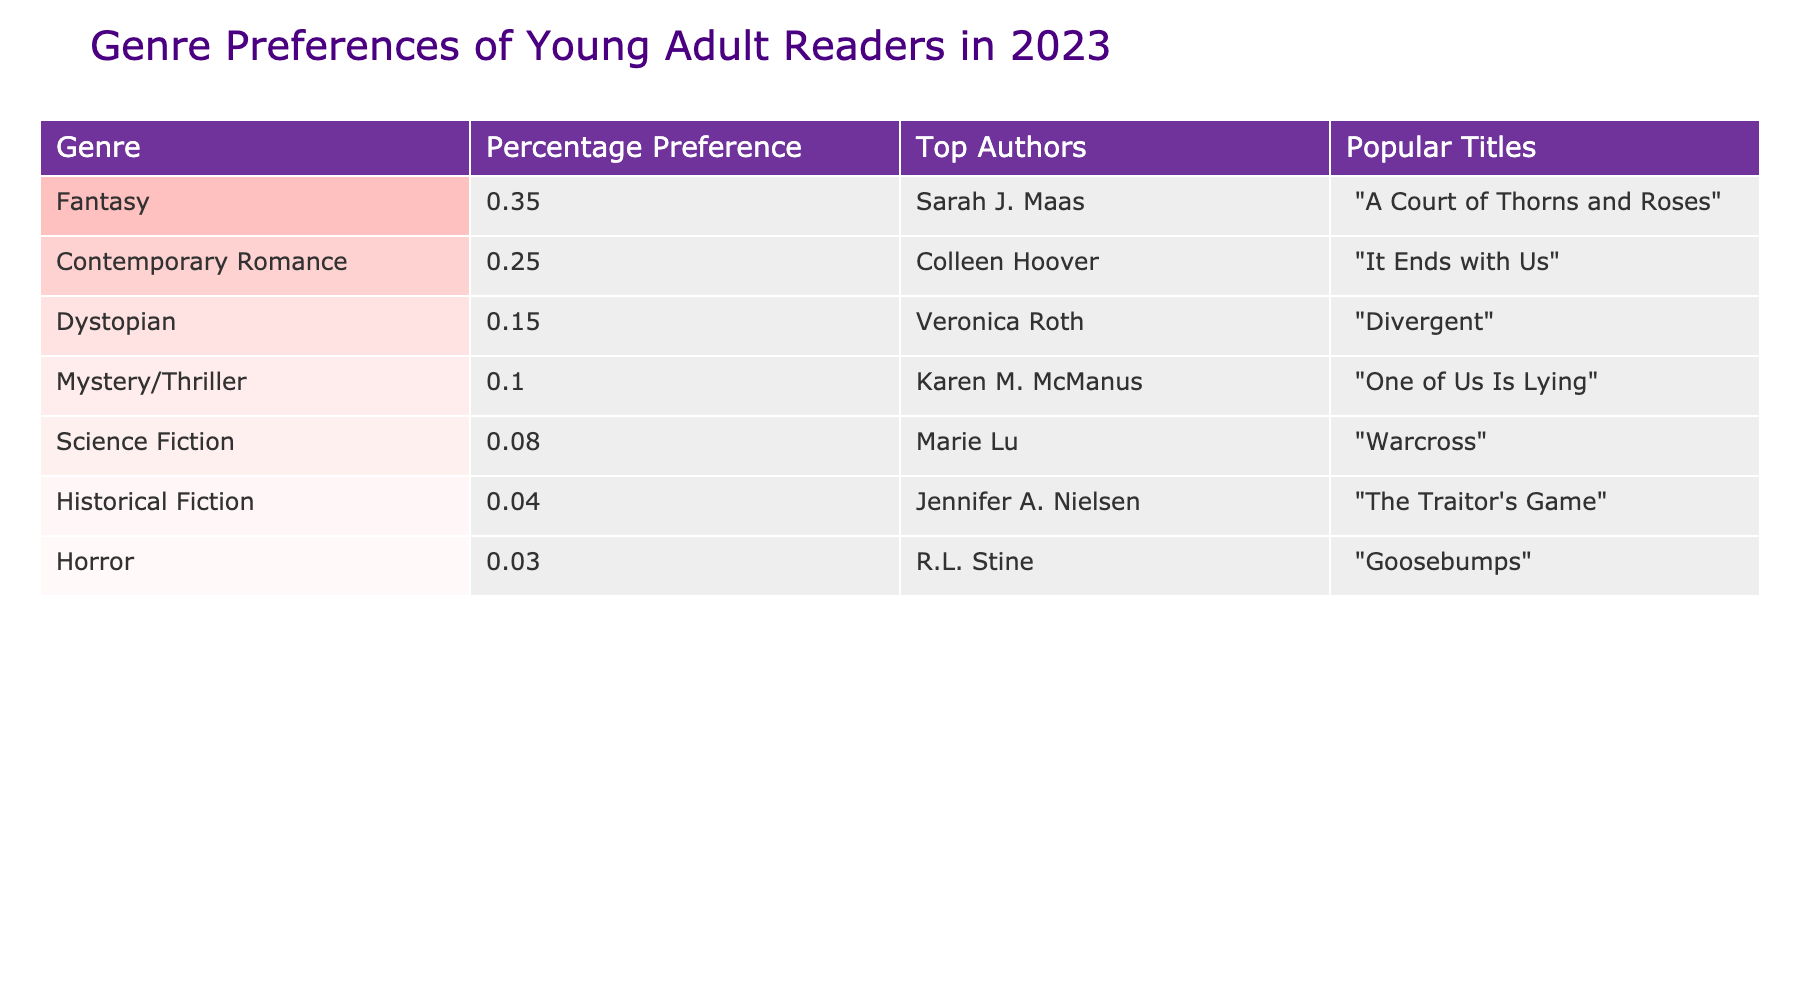What percentage of young adult readers prefer Fantasy? The table shows that the percentage preference for Fantasy is listed in the first row under "Percentage Preference," which is 35%.
Answer: 35% Which genre has the lowest percentage preference? By examining the "Percentage Preference" column, Horror is listed at 3%, which is the lowest percentage among all genres.
Answer: Horror Who is the top author for Contemporary Romance? The table lists Colleen Hoover as the top author for Contemporary Romance in the "Top Authors" column corresponding to the 25% preference in that genre.
Answer: Colleen Hoover What is the difference in percentage preference between Fantasy and Science Fiction? The percentage preference for Fantasy is 35% and for Science Fiction it is 8%. The difference is calculated as 35% - 8% = 27%.
Answer: 27% What is the combined percentage preference for Dystopian and Historical Fiction? The percentage preference for Dystopian is 15% and for Historical Fiction is 4%. Adding these together gives 15% + 4% = 19%.
Answer: 19% Is it true that more readers prefer Mystery/Thriller than Science Fiction? The table shows that Mystery/Thriller has a preference of 10% while Science Fiction has a preference of 8%. Since 10% is greater than 8%, the statement is true.
Answer: Yes If you ranked the genres from highest to lowest preference, where would Horror fall? Listing the genres by preference: 1) Fantasy (35%), 2) Contemporary Romance (25%), 3) Dystopian (15%), 4) Mystery/Thriller (10%), 5) Science Fiction (8%), 6) Historical Fiction (4%), 7) Horror (3%). Horror is ranked 7th among the genres.
Answer: 7th What percentage of young adult readers prefer genres other than Fantasy and Contemporary Romance combined? The percentage preference for Fantasy is 35% and for Contemporary Romance is 25%. Summing these gives 35% + 25% = 60%. To find the percentage for other genres, subtract this from 100%, resulting in 100% - 60% = 40%.
Answer: 40% 